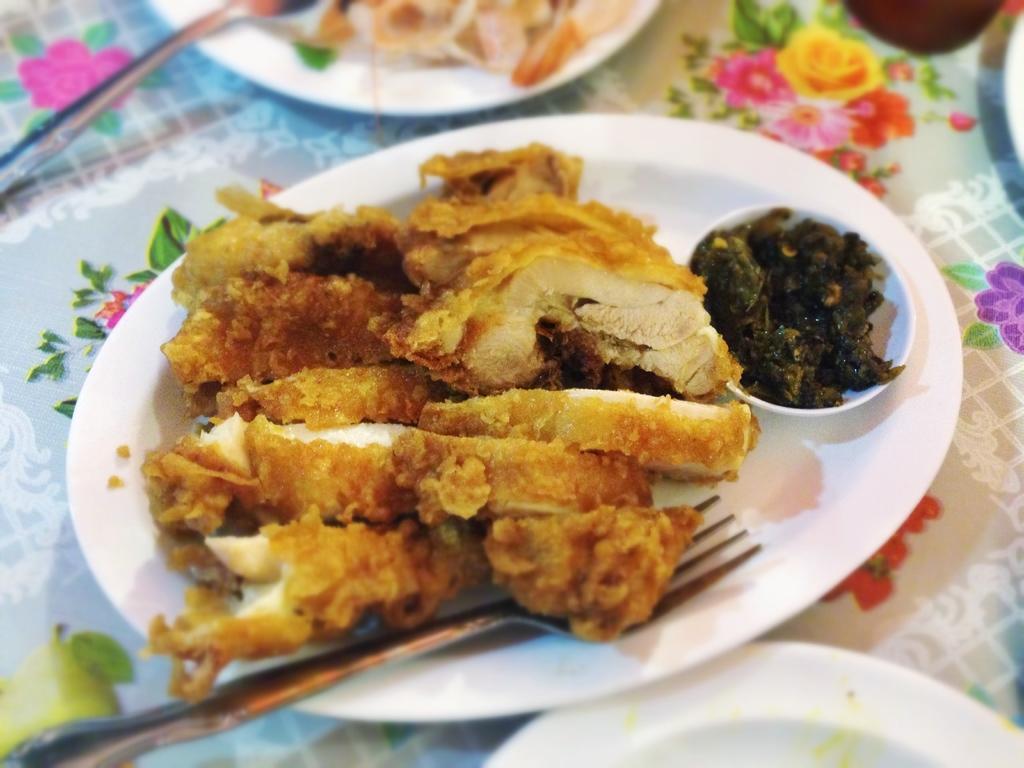Could you give a brief overview of what you see in this image? In this image we can see plates containing food, a spoon and a fork are placed on the surface. 